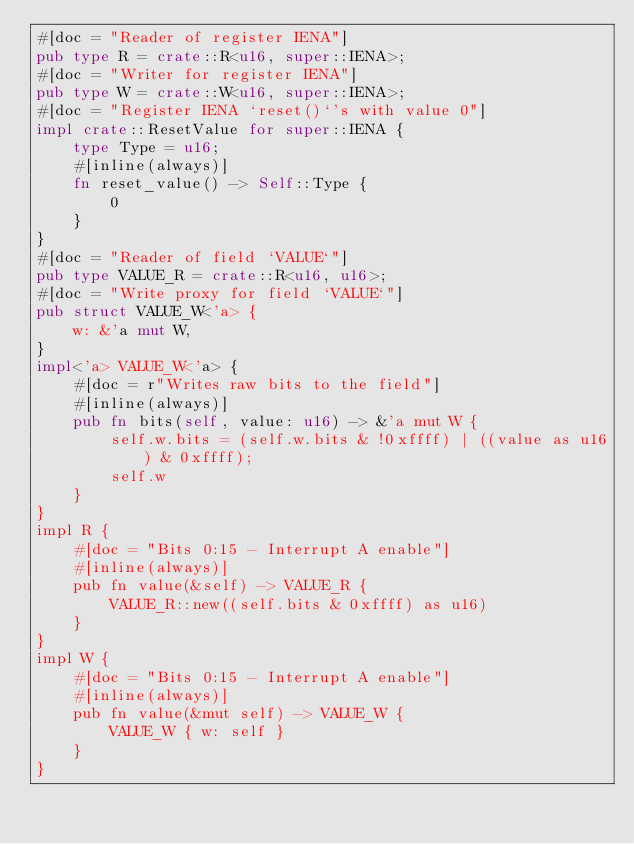<code> <loc_0><loc_0><loc_500><loc_500><_Rust_>#[doc = "Reader of register IENA"]
pub type R = crate::R<u16, super::IENA>;
#[doc = "Writer for register IENA"]
pub type W = crate::W<u16, super::IENA>;
#[doc = "Register IENA `reset()`'s with value 0"]
impl crate::ResetValue for super::IENA {
    type Type = u16;
    #[inline(always)]
    fn reset_value() -> Self::Type {
        0
    }
}
#[doc = "Reader of field `VALUE`"]
pub type VALUE_R = crate::R<u16, u16>;
#[doc = "Write proxy for field `VALUE`"]
pub struct VALUE_W<'a> {
    w: &'a mut W,
}
impl<'a> VALUE_W<'a> {
    #[doc = r"Writes raw bits to the field"]
    #[inline(always)]
    pub fn bits(self, value: u16) -> &'a mut W {
        self.w.bits = (self.w.bits & !0xffff) | ((value as u16) & 0xffff);
        self.w
    }
}
impl R {
    #[doc = "Bits 0:15 - Interrupt A enable"]
    #[inline(always)]
    pub fn value(&self) -> VALUE_R {
        VALUE_R::new((self.bits & 0xffff) as u16)
    }
}
impl W {
    #[doc = "Bits 0:15 - Interrupt A enable"]
    #[inline(always)]
    pub fn value(&mut self) -> VALUE_W {
        VALUE_W { w: self }
    }
}
</code> 